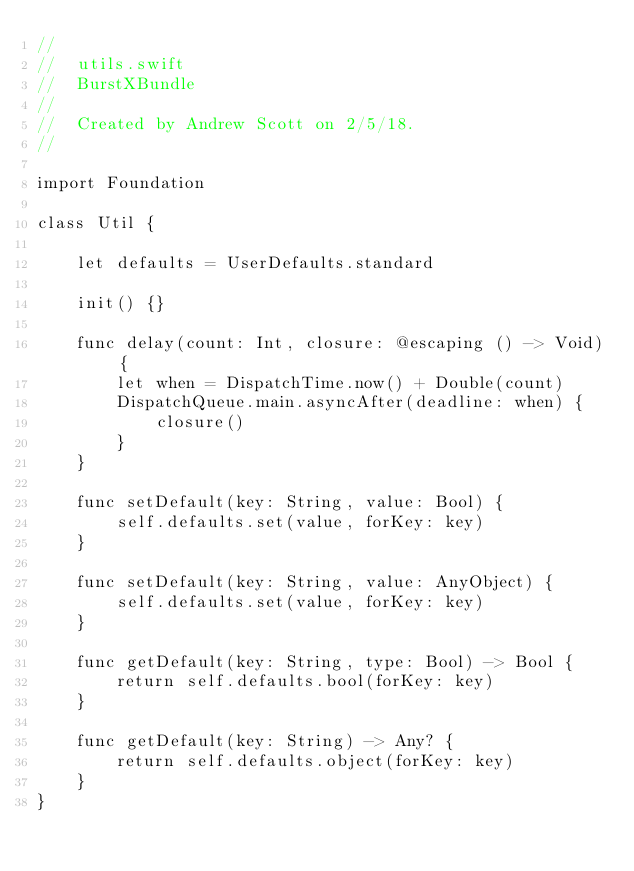Convert code to text. <code><loc_0><loc_0><loc_500><loc_500><_Swift_>//
//  utils.swift
//  BurstXBundle
//
//  Created by Andrew Scott on 2/5/18.
//

import Foundation

class Util {

    let defaults = UserDefaults.standard

    init() {}

    func delay(count: Int, closure: @escaping () -> Void) {
        let when = DispatchTime.now() + Double(count)
        DispatchQueue.main.asyncAfter(deadline: when) {
            closure()
        }
    }

    func setDefault(key: String, value: Bool) {
        self.defaults.set(value, forKey: key)
    }

    func setDefault(key: String, value: AnyObject) {
        self.defaults.set(value, forKey: key)
    }

    func getDefault(key: String, type: Bool) -> Bool {
        return self.defaults.bool(forKey: key)
    }

    func getDefault(key: String) -> Any? {
        return self.defaults.object(forKey: key)
    }
}
</code> 